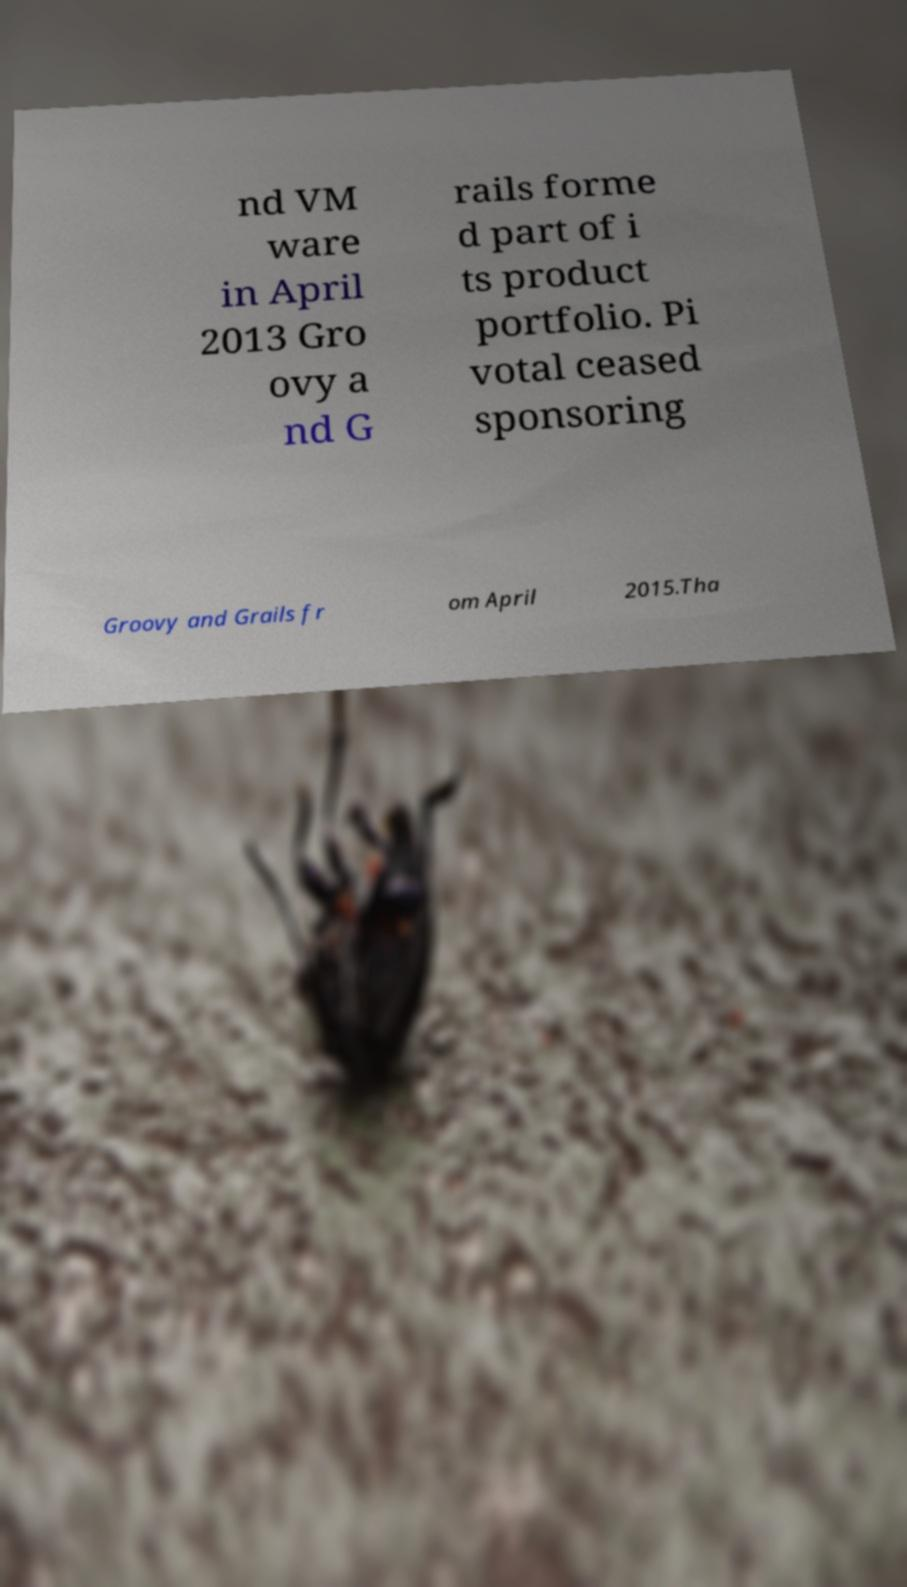Can you accurately transcribe the text from the provided image for me? nd VM ware in April 2013 Gro ovy a nd G rails forme d part of i ts product portfolio. Pi votal ceased sponsoring Groovy and Grails fr om April 2015.Tha 